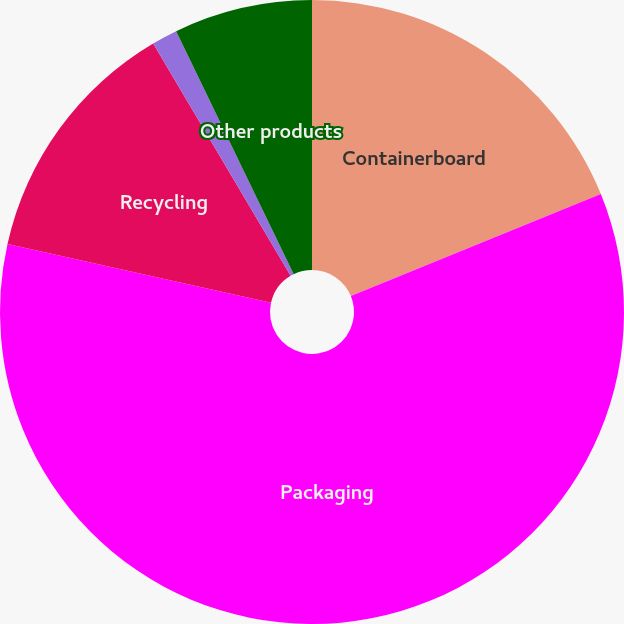<chart> <loc_0><loc_0><loc_500><loc_500><pie_chart><fcel>Containerboard<fcel>Packaging<fcel>Recycling<fcel>Kraft bags and sacks<fcel>Other products<nl><fcel>18.83%<fcel>59.67%<fcel>13.0%<fcel>1.33%<fcel>7.17%<nl></chart> 